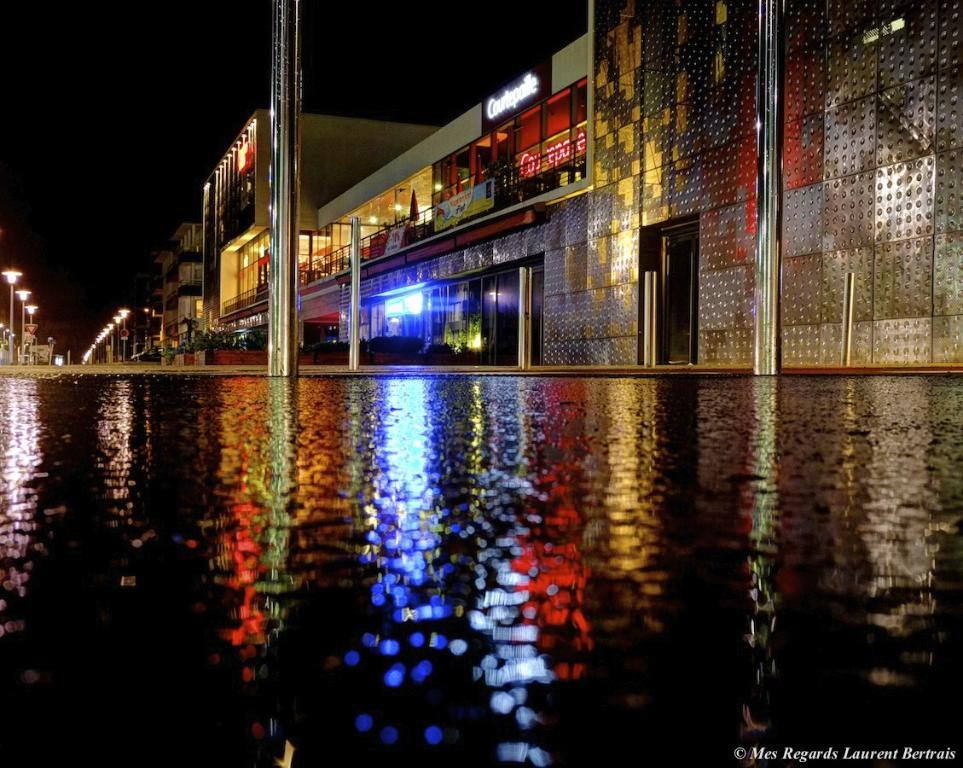What is the main feature in the picture? There is a pool in the picture. What can be seen on the right side of the picture? There are buildings on the right side of the picture. What else is present in the picture besides the pool and buildings? There are poles with lights in the picture. How would you describe the weather in the picture? The sky is clear in the picture, suggesting good weather. Can you see any dinosaurs roaming around the pool in the picture? No, there are no dinosaurs present in the image. 